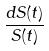Convert formula to latex. <formula><loc_0><loc_0><loc_500><loc_500>\frac { d S ( t ) } { S ( t ) }</formula> 